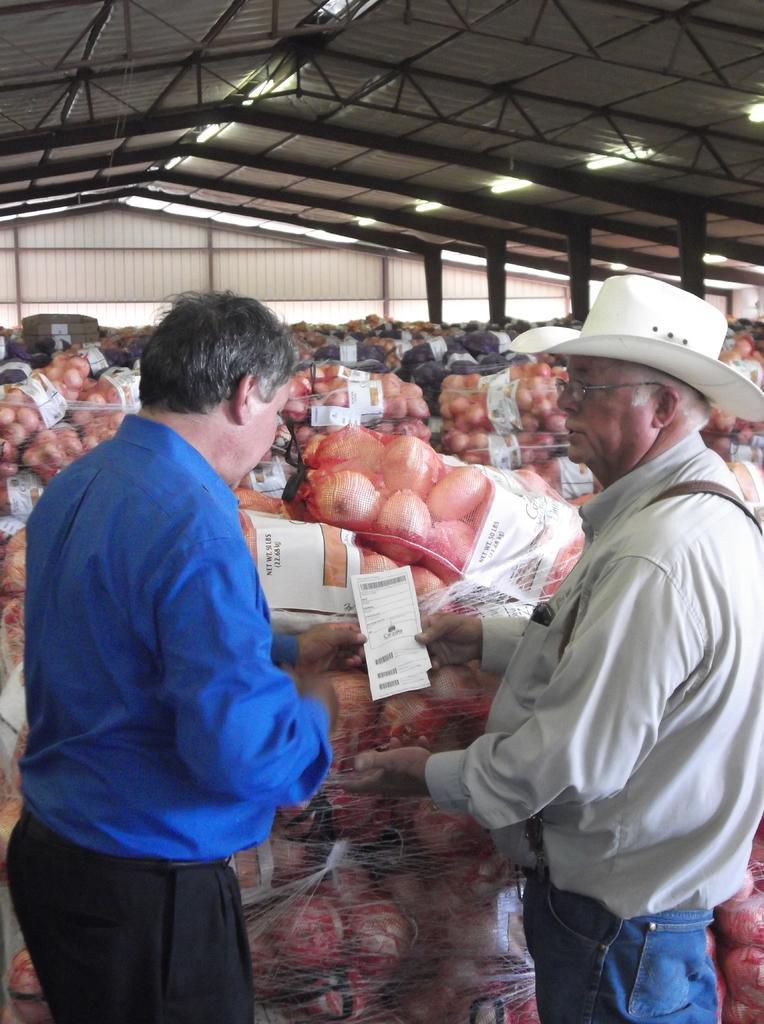Could you give a brief overview of what you see in this image? In this image, we can see two men standing, there are some objects placed in the bags. At the top we can see the shed. 